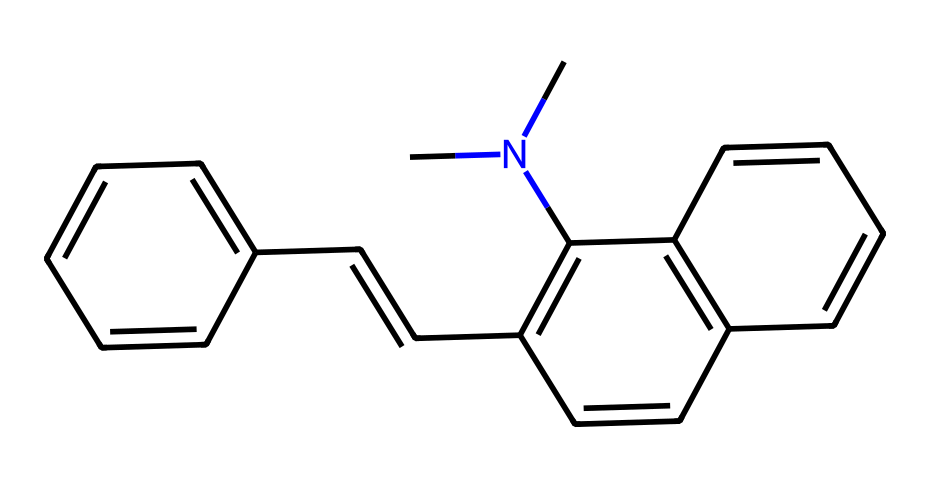What is the number of carbon atoms in the structure? The SMILES representation indicates that the structure contains multiple carbon atoms. By counting the 'C' characters in the SMILES, there are 22 carbon atoms total.
Answer: 22 How many nitrogen atoms are present in the chemical? In the provided SMILES representation, we can identify the presence of 1 nitrogen atom denoted by the 'N' in the structure. Therefore, there is 1 nitrogen atom.
Answer: 1 What type of isomerism is exhibited by this compound? The presence of double bonds and the potential for different configurations around these bonds indicates that this compound exhibits geometric isomerism (cis/trans).
Answer: geometric isomerism What are the possible geometric configurations of this compound? Given the presence of double bonds in the compound, the two major configurations are cis and trans forms, leading to the presence of two possible geometric isomers.
Answer: cis and trans Which part of this chemical contributes to its photochromic properties? The conjugated double bonds and the presence of specific functional groups in the chemical structure facilitate the reversible transformation in response to light, which is a characteristic of photochromic compounds.
Answer: conjugated double bonds How does the nitrogen atom affect the isomerism of this chemical? The nitrogen atom introduces steric and electronic factors that can influence the overall geometry of the molecule and potentially affect the orientation of substituents around double bonds, thereby influencing isomerism.
Answer: influences isomerism What is the total number of double bonds in this compound? By analyzing the SMILES representation, we can count the number of times the '=' symbol appears, which indicates the presence of double bonds. There are a total of 5 double bonds present.
Answer: 5 